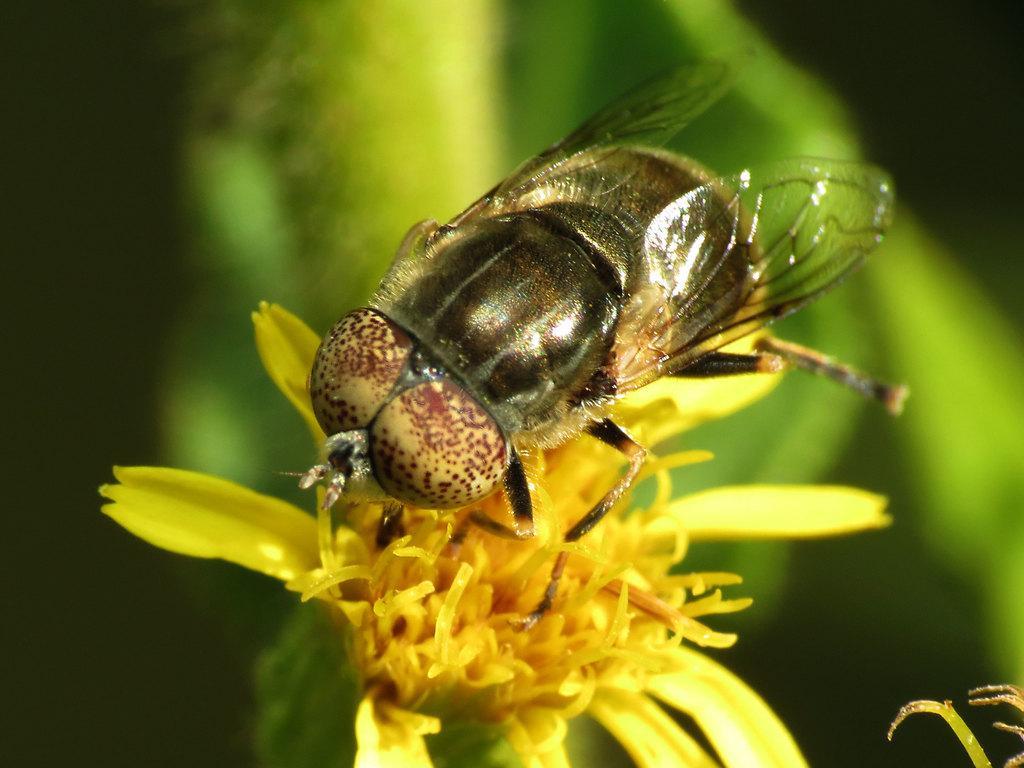Describe this image in one or two sentences. In this picture we can see a honey bee sitting on the yellow flower. Behind there is a blur background. 